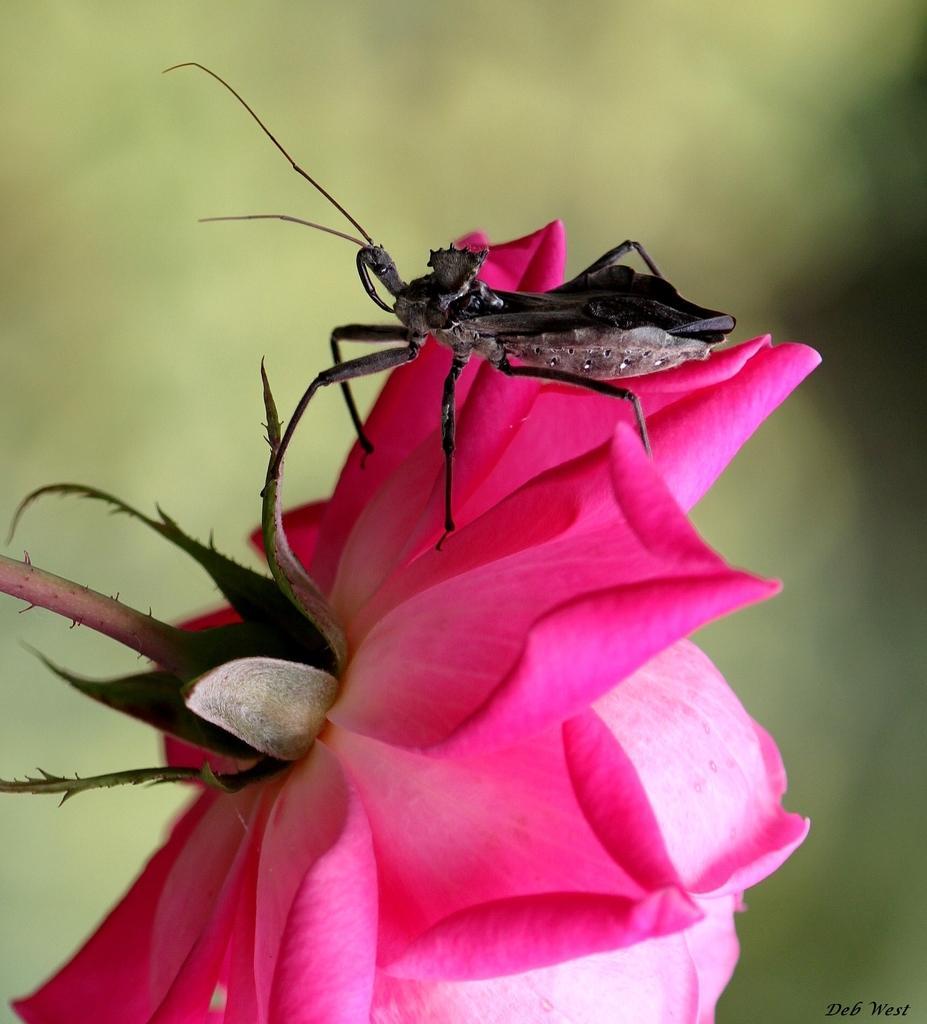How would you summarize this image in a sentence or two? In this image there is a rose flower on that there is an insect in the background it is blurred. 